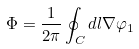Convert formula to latex. <formula><loc_0><loc_0><loc_500><loc_500>\Phi = \frac { 1 } { 2 \pi } \oint _ { C } d { l } \nabla \varphi _ { 1 }</formula> 